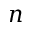Convert formula to latex. <formula><loc_0><loc_0><loc_500><loc_500>n</formula> 